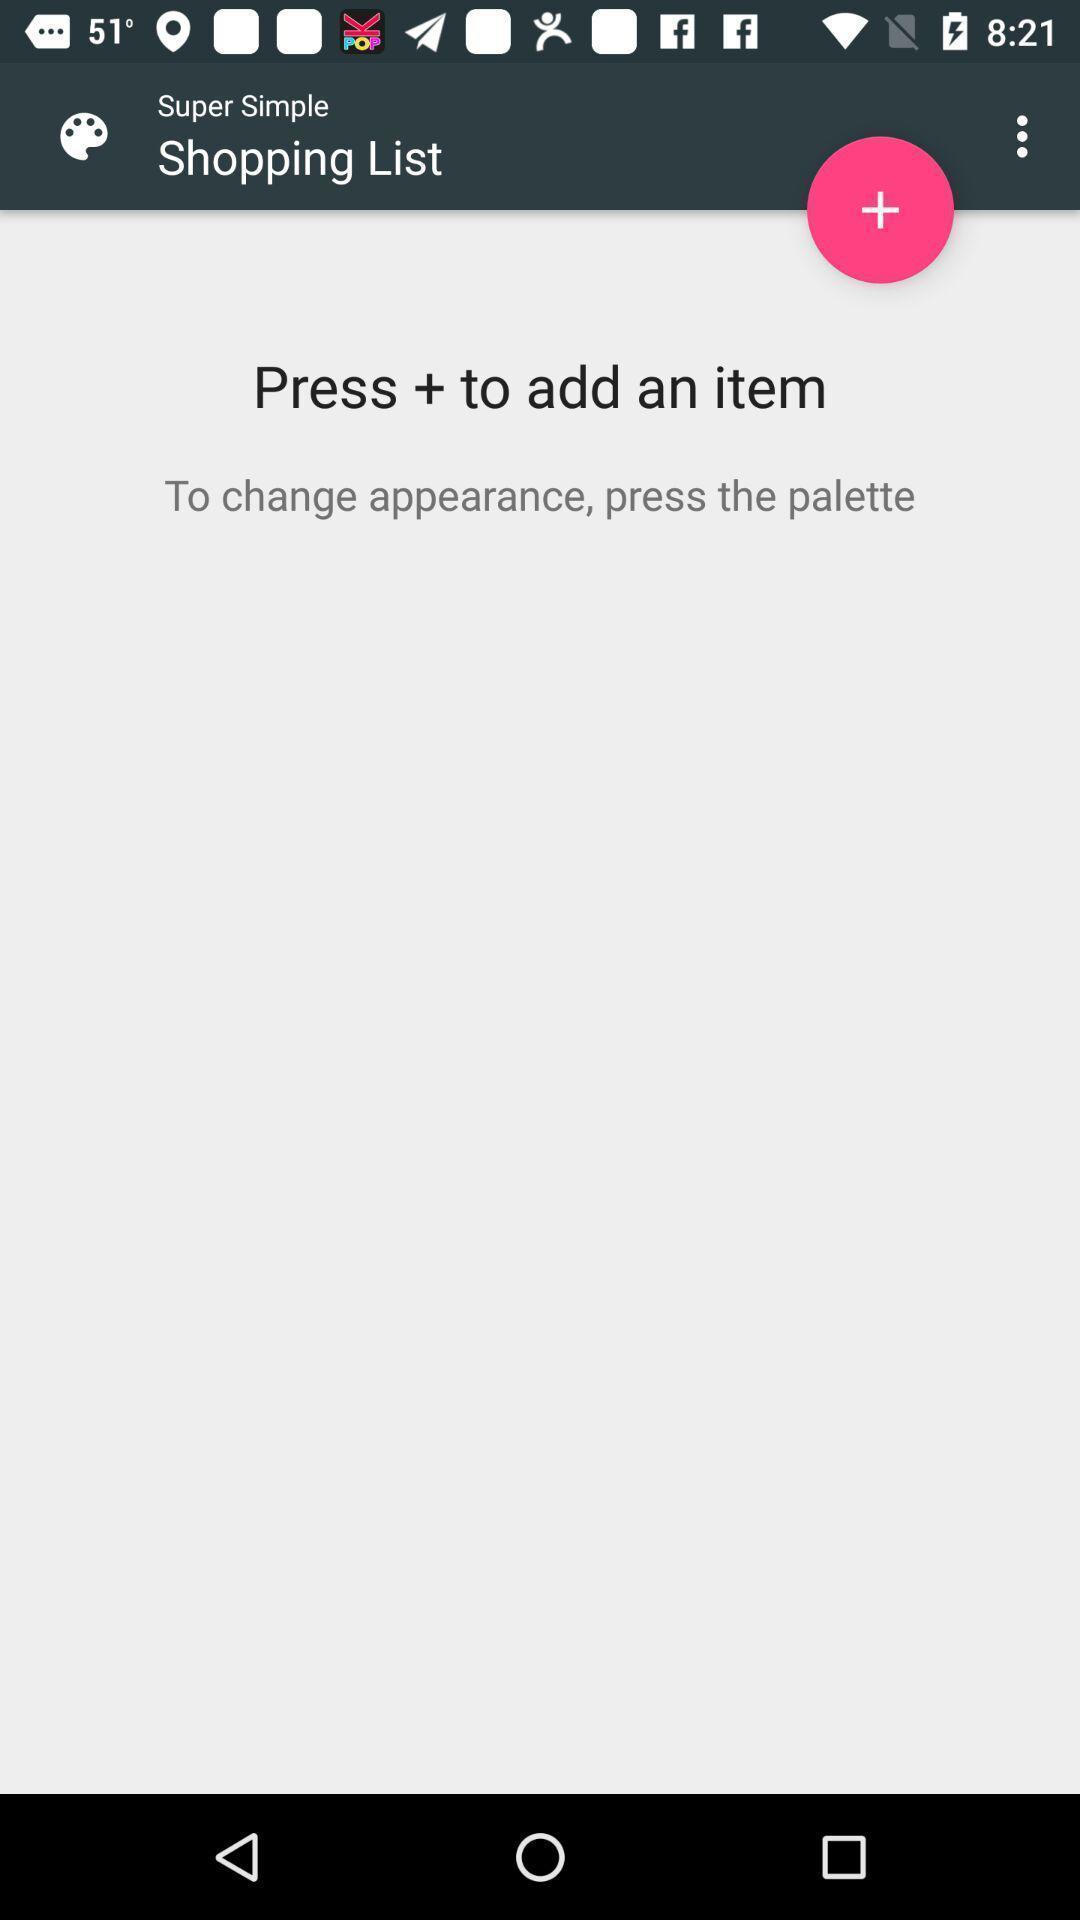Tell me about the visual elements in this screen capture. Shopping list page of a shopping application. 